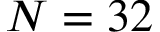Convert formula to latex. <formula><loc_0><loc_0><loc_500><loc_500>N = 3 2</formula> 